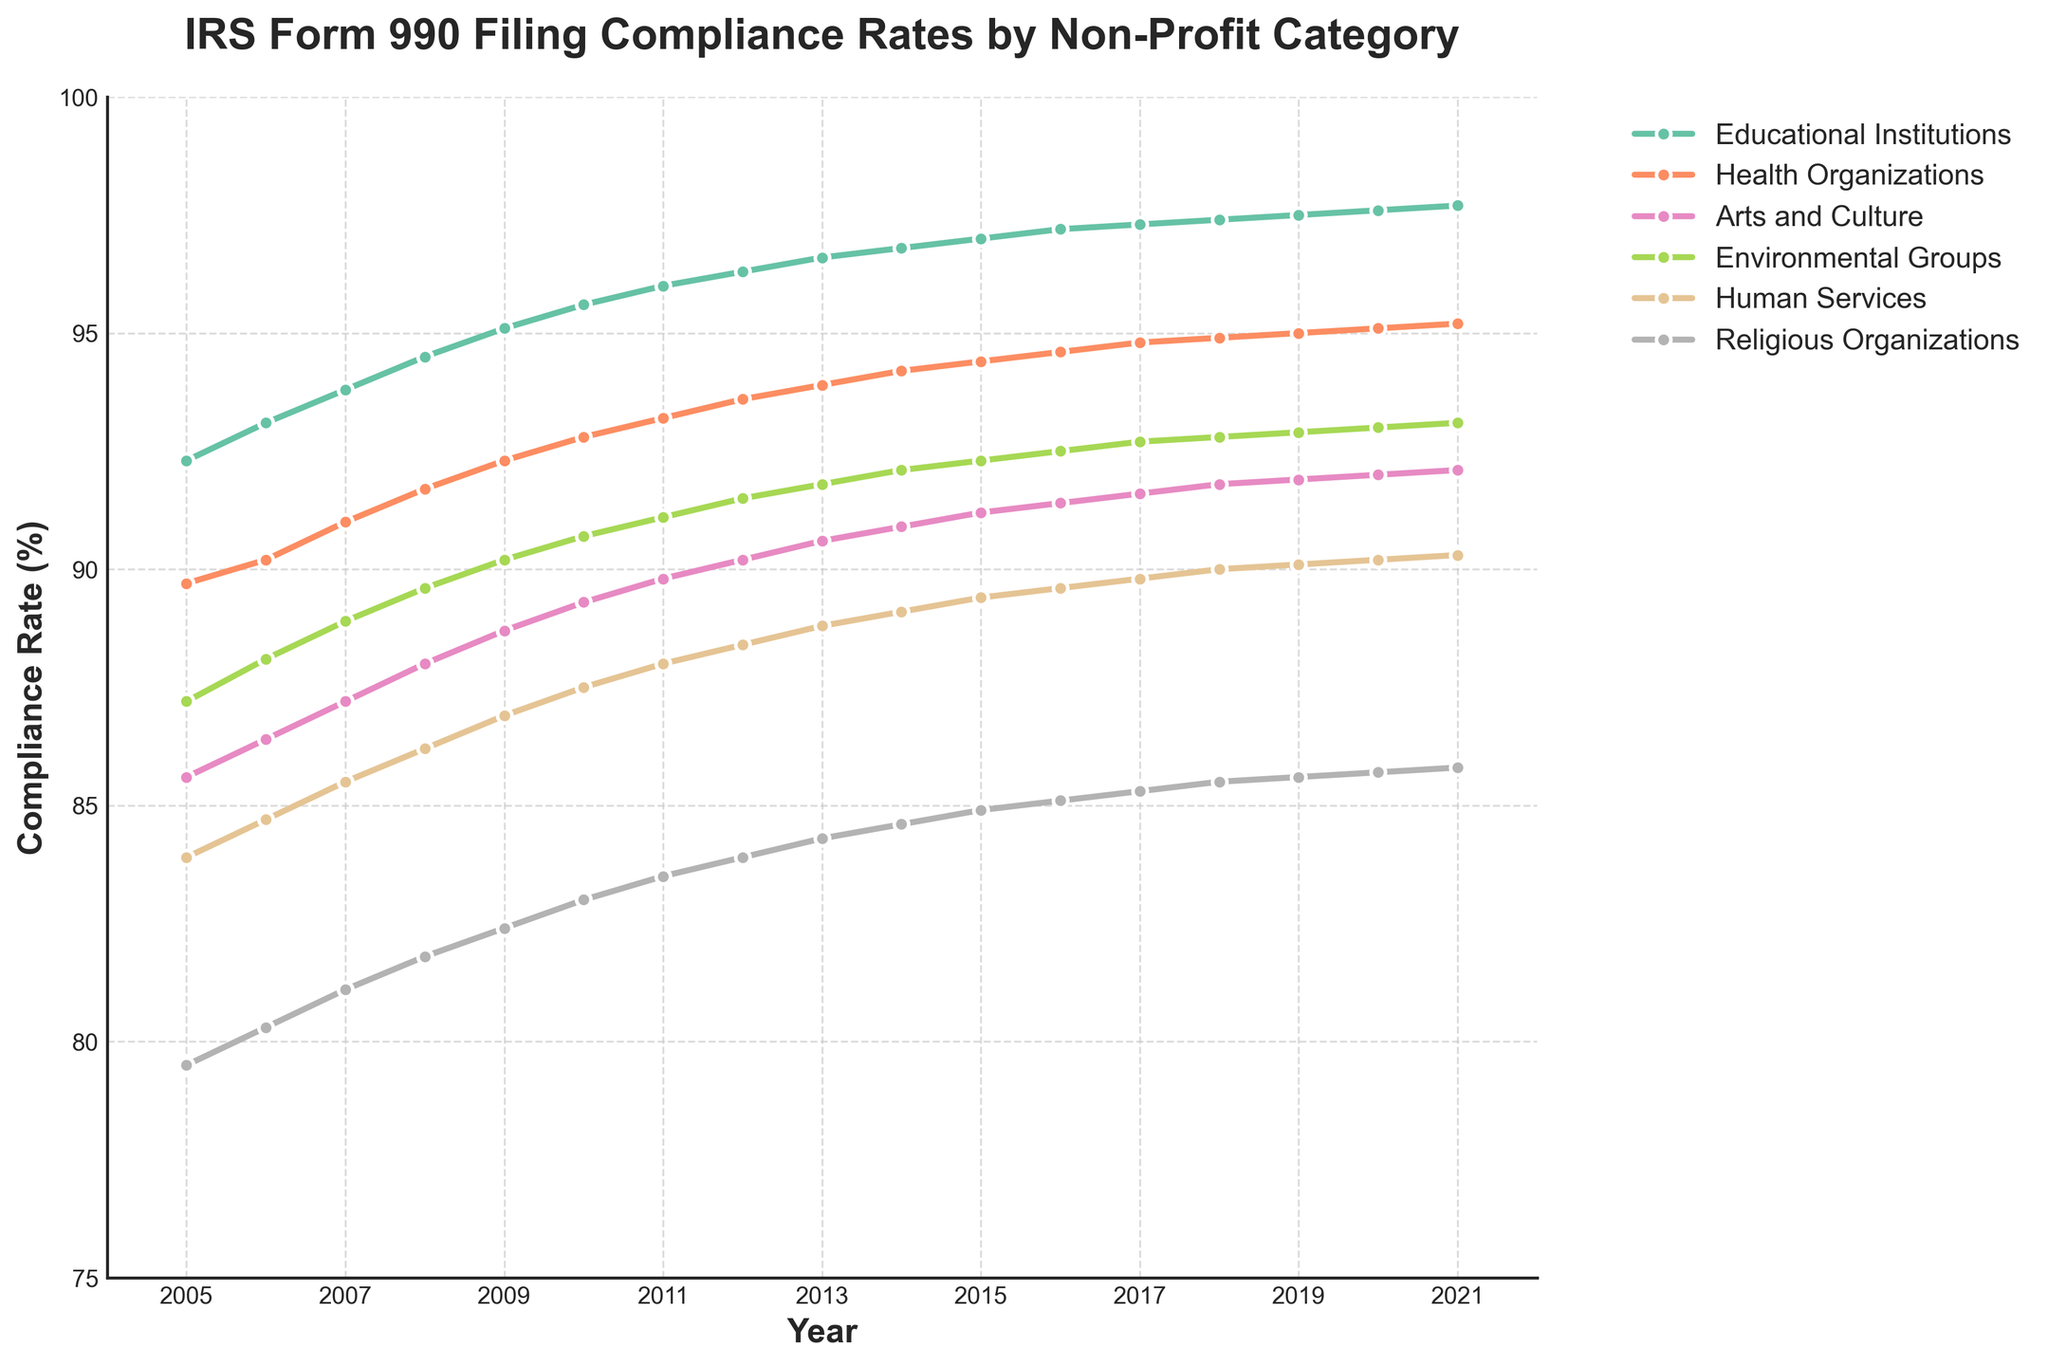Which non-profit category had the lowest compliance rate in 2005? By examining the line chart, identify the category line that is visually lowest for the year 2005, which corresponds to the lowest compliance rate in that year.
Answer: Religious Organizations How much did the compliance rate for Educational Institutions increase from 2005 to 2021? Find the compliance rate for Educational Institutions in both 2005 and 2021, then compute the difference by subtracting the 2005 value from the 2021 value (97.7 - 92.3).
Answer: 5.4% Which two non-profit categories had the closest compliance rates in 2021? Examine the compliance rates of all non-profit categories for the year 2021. Identify the two categories whose lines are closest together on the y-axis for that year.
Answer: Health Organizations and Arts and Culture What is the average compliance rate for Health Organizations over the entire period? Sum all the compliance rates for Health Organizations from 2005 to 2021, then divide by the number of years (17). (89.7 + 90.2 + 91.0 + 91.7 + 92.3 + 92.8 + 93.2 + 93.6 + 93.9 + 94.2 + 94.4 + 94.6 + 94.8 + 94.9 + 95.0 + 95.1 + 95.2) / 17.
Answer: 93.08% Which non-profit category showed the most consistent increase in compliance rates from 2005 to 2021? Look for the category line that rises the most consistently each year without any decreases; inspector for consistent upward trends in the plot.
Answer: Educational Institutions Was there any year when the compliance rate for Health Organizations was higher than for Educational Institutions? Compare the lines for Health Organizations and Educational Institutions for each year to see if the Health Organizations line ever surpasses the Educational Institutions line.
Answer: No In which year did the Human Services category first surpass a 90% compliance rate? Examine the line for Human Services and identify the year where it first crosses the 90% threshold.
Answer: 2018 What is the difference in compliance rates between Environmental Groups and Human Services in 2010? Find the compliance rates for both Environmental Groups and Human Services in 2010 and subtract the rate of Human Services from the rate of Environmental Groups (90.7 - 87.5).
Answer: 3.2% Which year shows the highest overall compliance rate among all categories? Inspect all individual data points for each year and identify the highest compliance rate across all categories.
Answer: 2021 (Educational Institutions with 97.7%) Does the compliance rate for Arts and Culture ever exceed 92%? Track the line representing Arts and Culture through the plot and check if it ever touches or exceeds the 92% mark.
Answer: No 